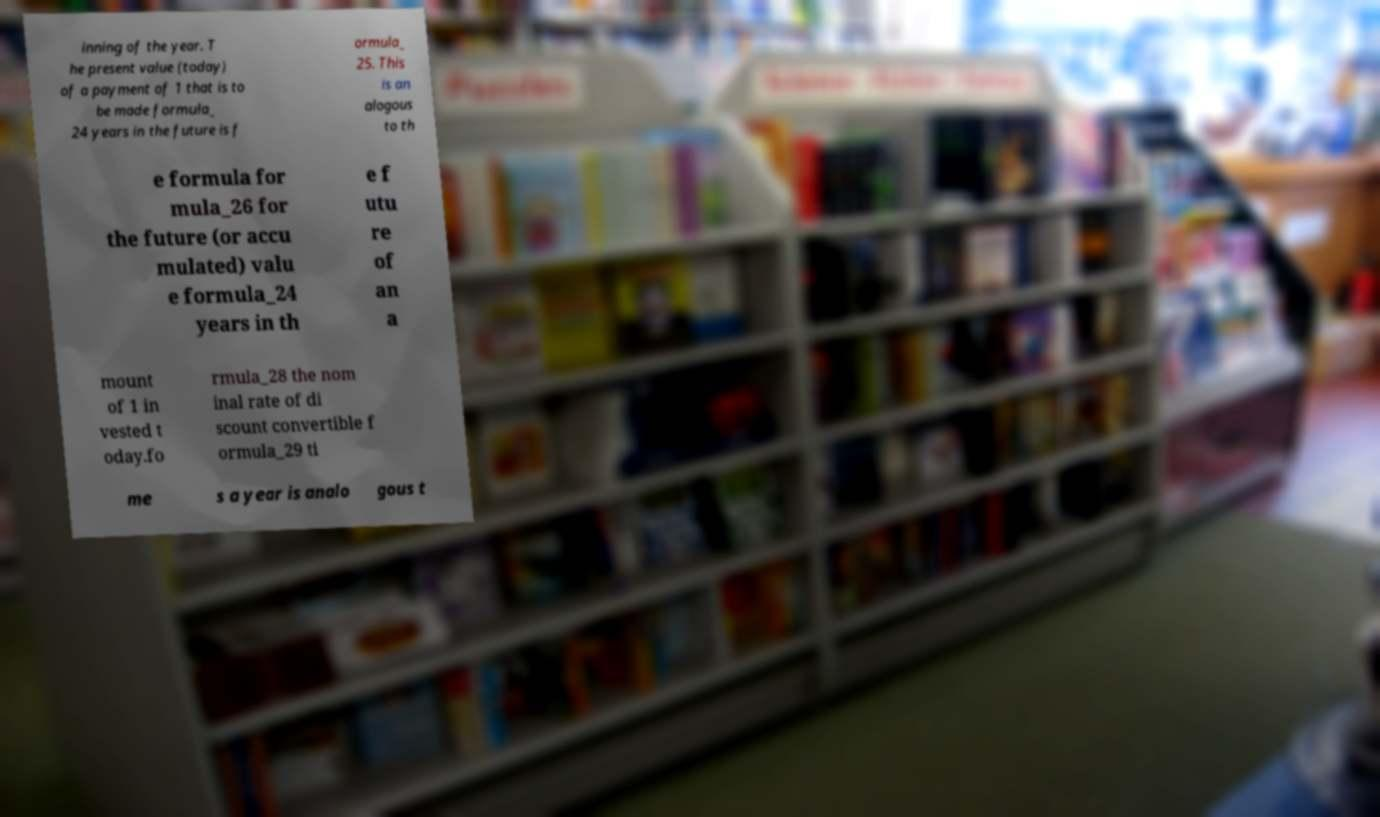Could you assist in decoding the text presented in this image and type it out clearly? inning of the year. T he present value (today) of a payment of 1 that is to be made formula_ 24 years in the future is f ormula_ 25. This is an alogous to th e formula for mula_26 for the future (or accu mulated) valu e formula_24 years in th e f utu re of an a mount of 1 in vested t oday.fo rmula_28 the nom inal rate of di scount convertible f ormula_29 ti me s a year is analo gous t 